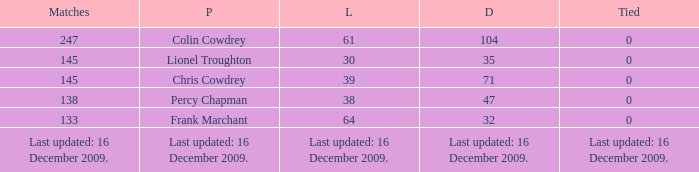Name the tie that has 71 drawn 0.0. Would you be able to parse every entry in this table? {'header': ['Matches', 'P', 'L', 'D', 'Tied'], 'rows': [['247', 'Colin Cowdrey', '61', '104', '0'], ['145', 'Lionel Troughton', '30', '35', '0'], ['145', 'Chris Cowdrey', '39', '71', '0'], ['138', 'Percy Chapman', '38', '47', '0'], ['133', 'Frank Marchant', '64', '32', '0'], ['Last updated: 16 December 2009.', 'Last updated: 16 December 2009.', 'Last updated: 16 December 2009.', 'Last updated: 16 December 2009.', 'Last updated: 16 December 2009.']]} 